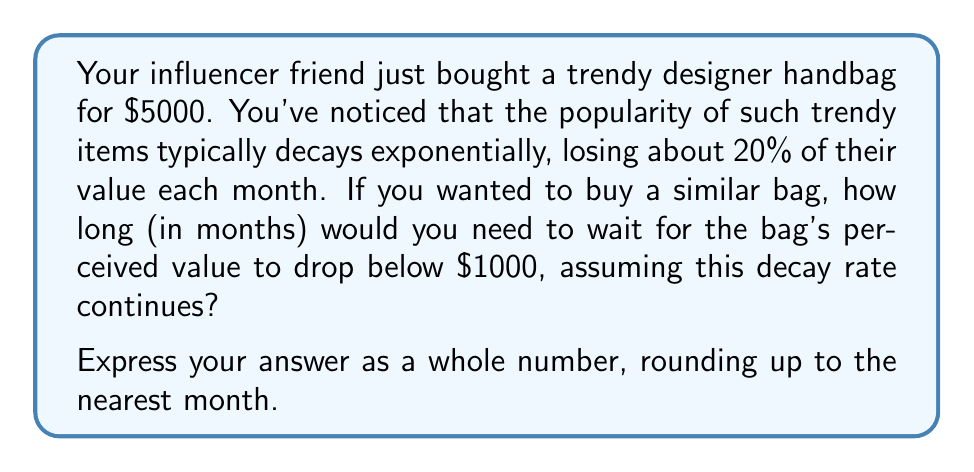Solve this math problem. Let's approach this step-by-step:

1) The initial value of the bag is $5000, and we want to know when it drops below $1000.

2) The decay rate is 20% per month, which means 80% of the value remains each month.

3) We can express this as an exponential decay function:
   $$ V(t) = 5000 \cdot (0.8)^t $$
   where $V(t)$ is the value after $t$ months.

4) We want to find $t$ when $V(t) < 1000$:
   $$ 1000 > 5000 \cdot (0.8)^t $$

5) Dividing both sides by 5000:
   $$ 0.2 > (0.8)^t $$

6) Taking the natural log of both sides:
   $$ \ln(0.2) > t \cdot \ln(0.8) $$

7) Solving for $t$:
   $$ t > \frac{\ln(0.2)}{\ln(0.8)} \approx 7.57 $$

8) Since we need to round up to the nearest month, the answer is 8 months.

This calculation shows how quickly trendy items can lose their perceived value, which might help alleviate feelings of envy towards your influencer friend's purchases.
Answer: 8 months 